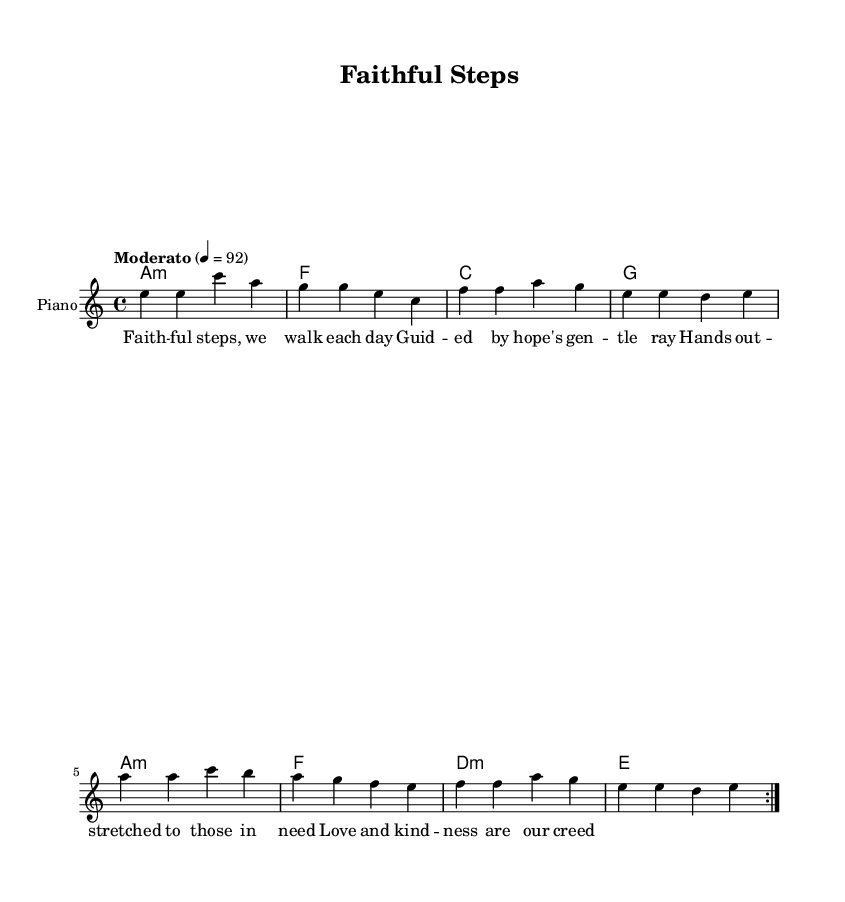What is the key signature of this music? The key signature is A minor, which is indicated by having no sharps or flats. The key is specified at the beginning of the score with "a minor."
Answer: A minor What is the time signature of this music? The time signature is 4/4, which is clearly marked at the beginning of the score as "4/4." This indicates that there are four beats per measure.
Answer: 4/4 What is the tempo marking for this piece? The tempo marking is "Moderato," which is shown in the score along with the metronome marking of 4 = 92. This indicates a moderate speed for the performance.
Answer: Moderato How many measures are repeated in the melody? The melody has a repeat sign indicating that the first section, consisting of 8 measures, is played twice. This is typical in music to establish a theme.
Answer: 8 What is the lyric theme of the first verse? The theme of the first verse revolves around compassion and support, as evident from the lyrics which speak to love, kindness, and helping those in need.
Answer: Compassion Which chord is played during the lyrics "Guided by hope's gentle ray"? The corresponding chord during these lyrics is the F major chord, as indicated in the score at that lyric position in the chord progression.
Answer: F What type of music fusion does this piece represent? This piece represents a fusion of soul and Latin-blues, combining spiritual themes with musical diversity characteristic of both genres.
Answer: Soulful Latin-blues fusion 